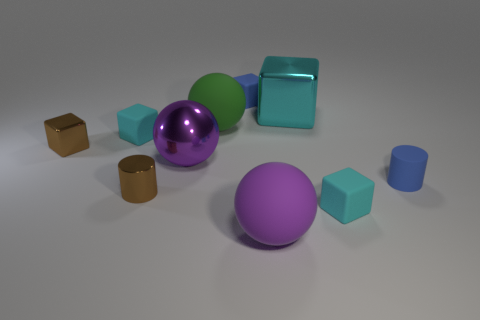There is a small rubber thing that is in front of the shiny cylinder; does it have the same shape as the cyan rubber object behind the tiny blue rubber cylinder?
Offer a very short reply. Yes. Is there a small brown block that has the same material as the large cyan object?
Provide a succinct answer. Yes. What color is the shiny sphere that is left of the big matte thing behind the rubber cylinder that is behind the small brown cylinder?
Ensure brevity in your answer.  Purple. Do the big purple ball that is in front of the blue cylinder and the tiny block in front of the small metal cube have the same material?
Your answer should be very brief. Yes. There is a tiny brown thing that is behind the blue matte cylinder; what shape is it?
Offer a terse response. Cube. What number of objects are small gray metallic cubes or big metal things that are left of the tiny blue rubber cube?
Give a very brief answer. 1. Are the small brown cylinder and the blue cube made of the same material?
Your answer should be compact. No. Are there an equal number of large purple rubber balls that are left of the green object and brown metal objects behind the blue cylinder?
Keep it short and to the point. No. There is a tiny brown metal block; what number of cyan blocks are behind it?
Offer a terse response. 2. How many things are either large blue metal spheres or big purple balls?
Provide a succinct answer. 2. 